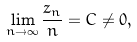<formula> <loc_0><loc_0><loc_500><loc_500>\lim _ { n \rightarrow \infty } \frac { z _ { n } } { n } = C \not = 0 ,</formula> 